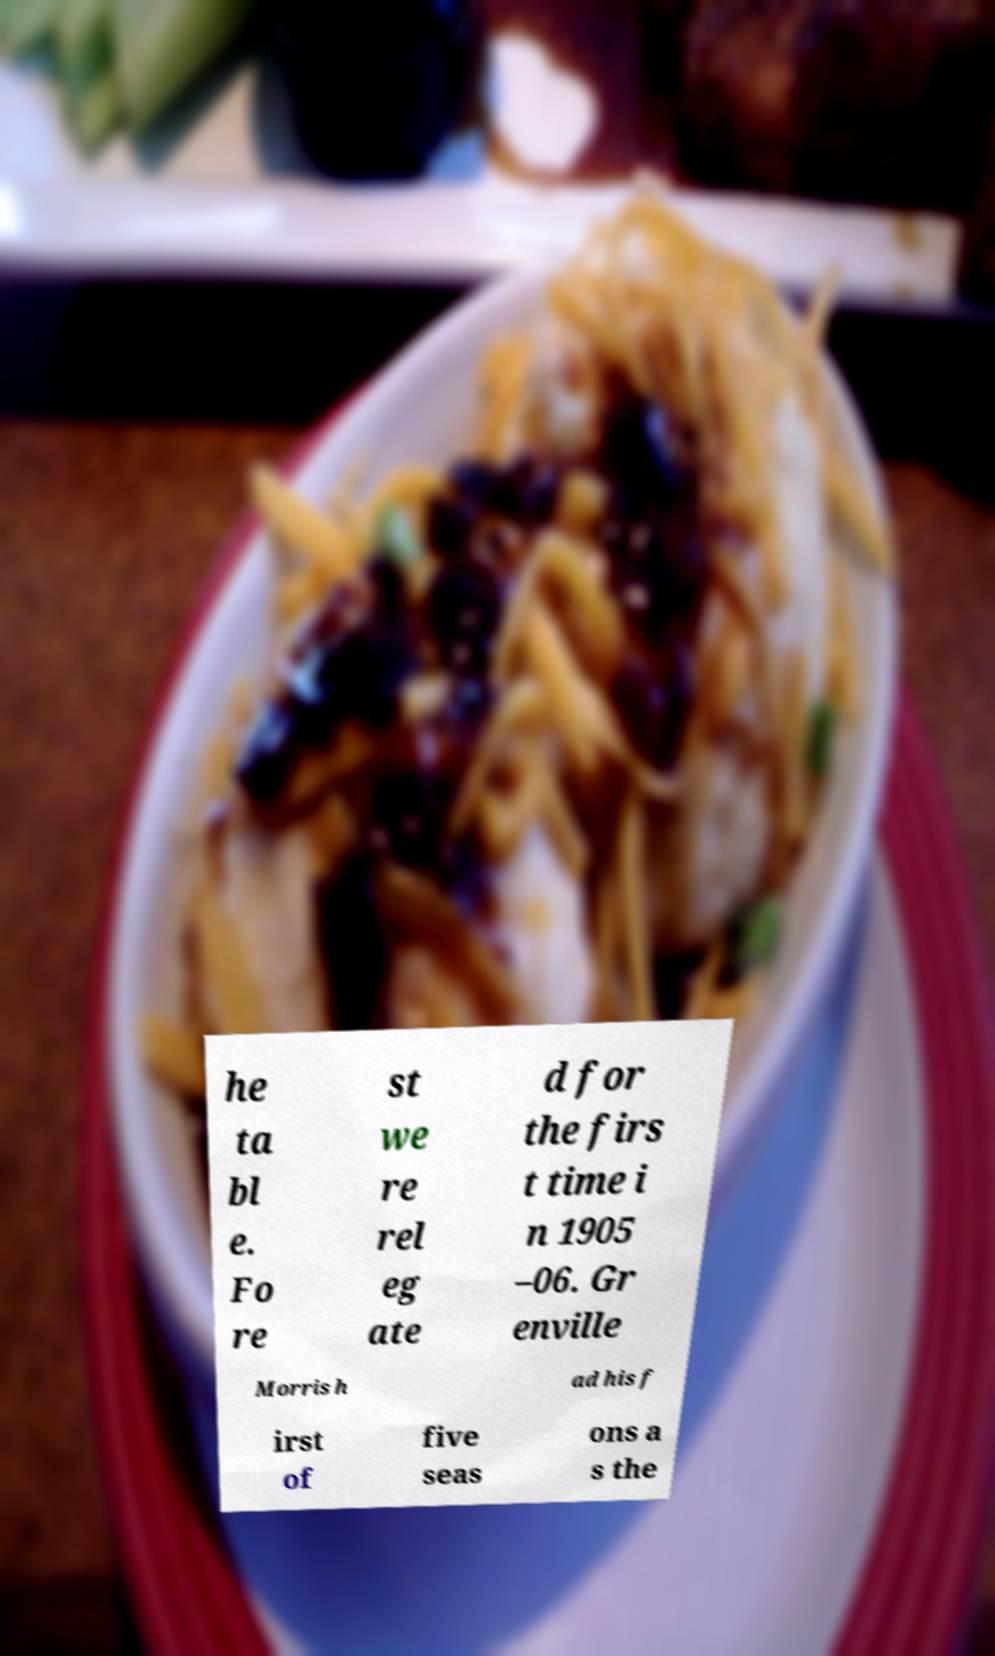Can you read and provide the text displayed in the image?This photo seems to have some interesting text. Can you extract and type it out for me? he ta bl e. Fo re st we re rel eg ate d for the firs t time i n 1905 –06. Gr enville Morris h ad his f irst of five seas ons a s the 